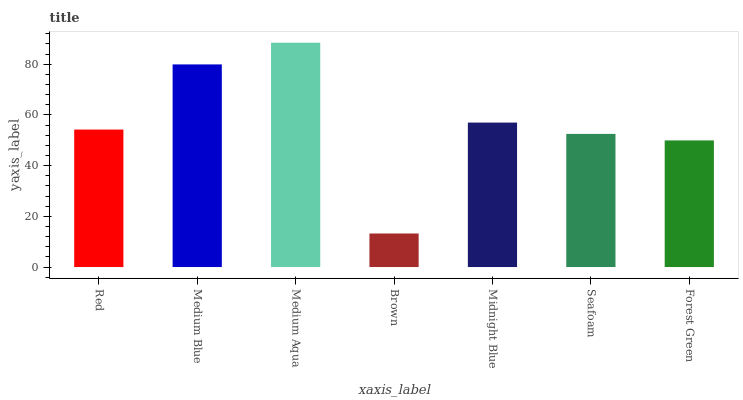Is Brown the minimum?
Answer yes or no. Yes. Is Medium Aqua the maximum?
Answer yes or no. Yes. Is Medium Blue the minimum?
Answer yes or no. No. Is Medium Blue the maximum?
Answer yes or no. No. Is Medium Blue greater than Red?
Answer yes or no. Yes. Is Red less than Medium Blue?
Answer yes or no. Yes. Is Red greater than Medium Blue?
Answer yes or no. No. Is Medium Blue less than Red?
Answer yes or no. No. Is Red the high median?
Answer yes or no. Yes. Is Red the low median?
Answer yes or no. Yes. Is Midnight Blue the high median?
Answer yes or no. No. Is Forest Green the low median?
Answer yes or no. No. 